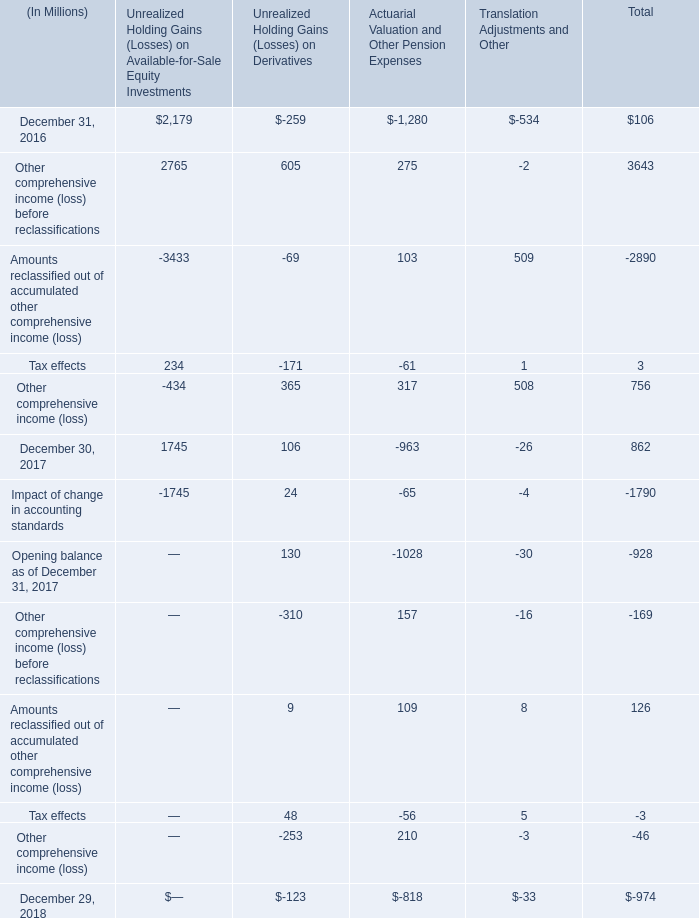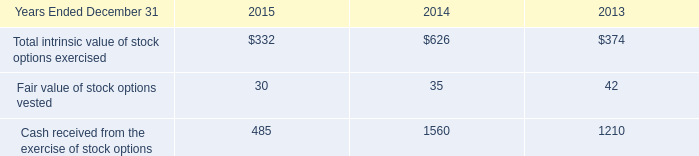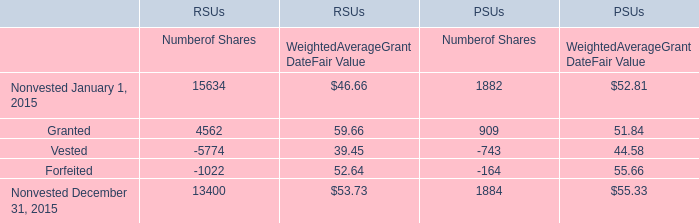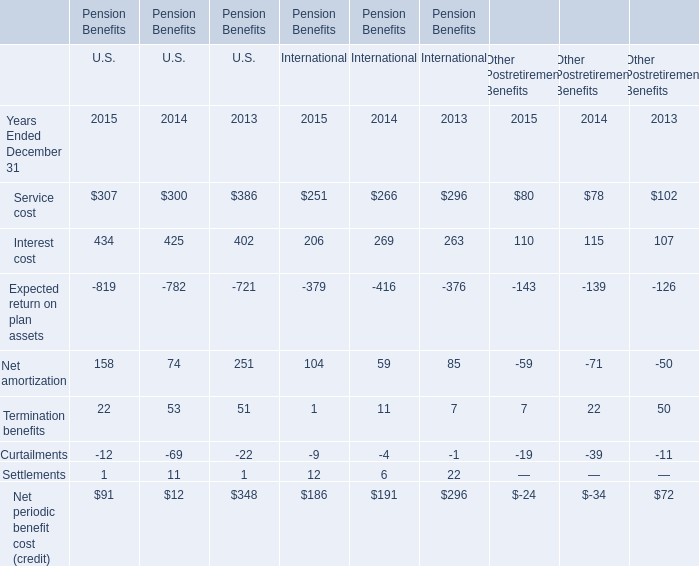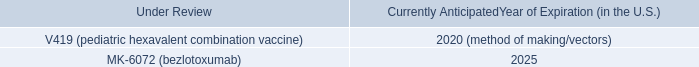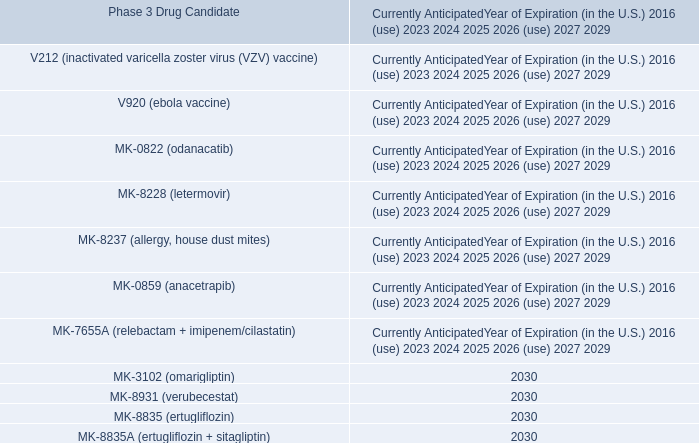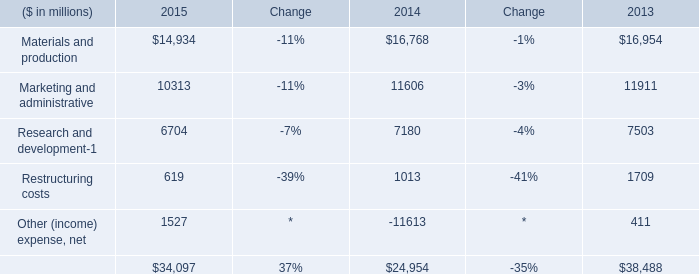What is the growing rate of Fair value of stock options vested in the year with the most Total intrinsic value of stock options exercised? 
Computations: ((30 - 35) / 35)
Answer: -0.14286. 